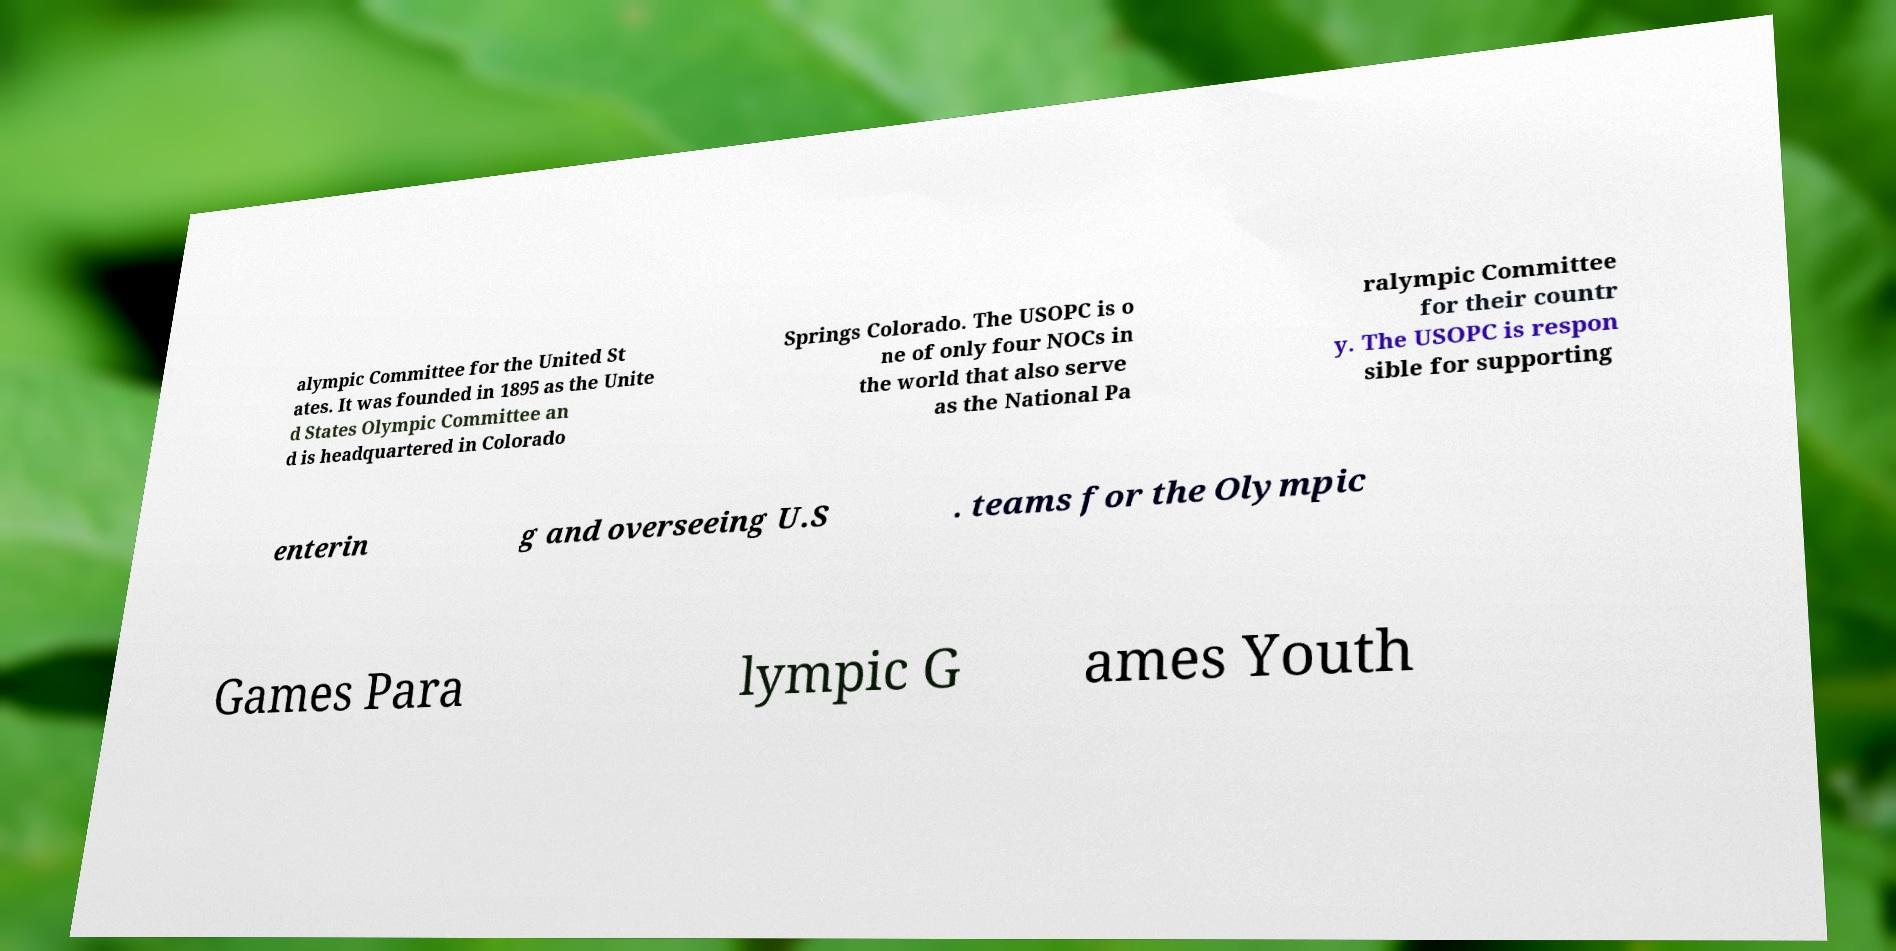I need the written content from this picture converted into text. Can you do that? alympic Committee for the United St ates. It was founded in 1895 as the Unite d States Olympic Committee an d is headquartered in Colorado Springs Colorado. The USOPC is o ne of only four NOCs in the world that also serve as the National Pa ralympic Committee for their countr y. The USOPC is respon sible for supporting enterin g and overseeing U.S . teams for the Olympic Games Para lympic G ames Youth 